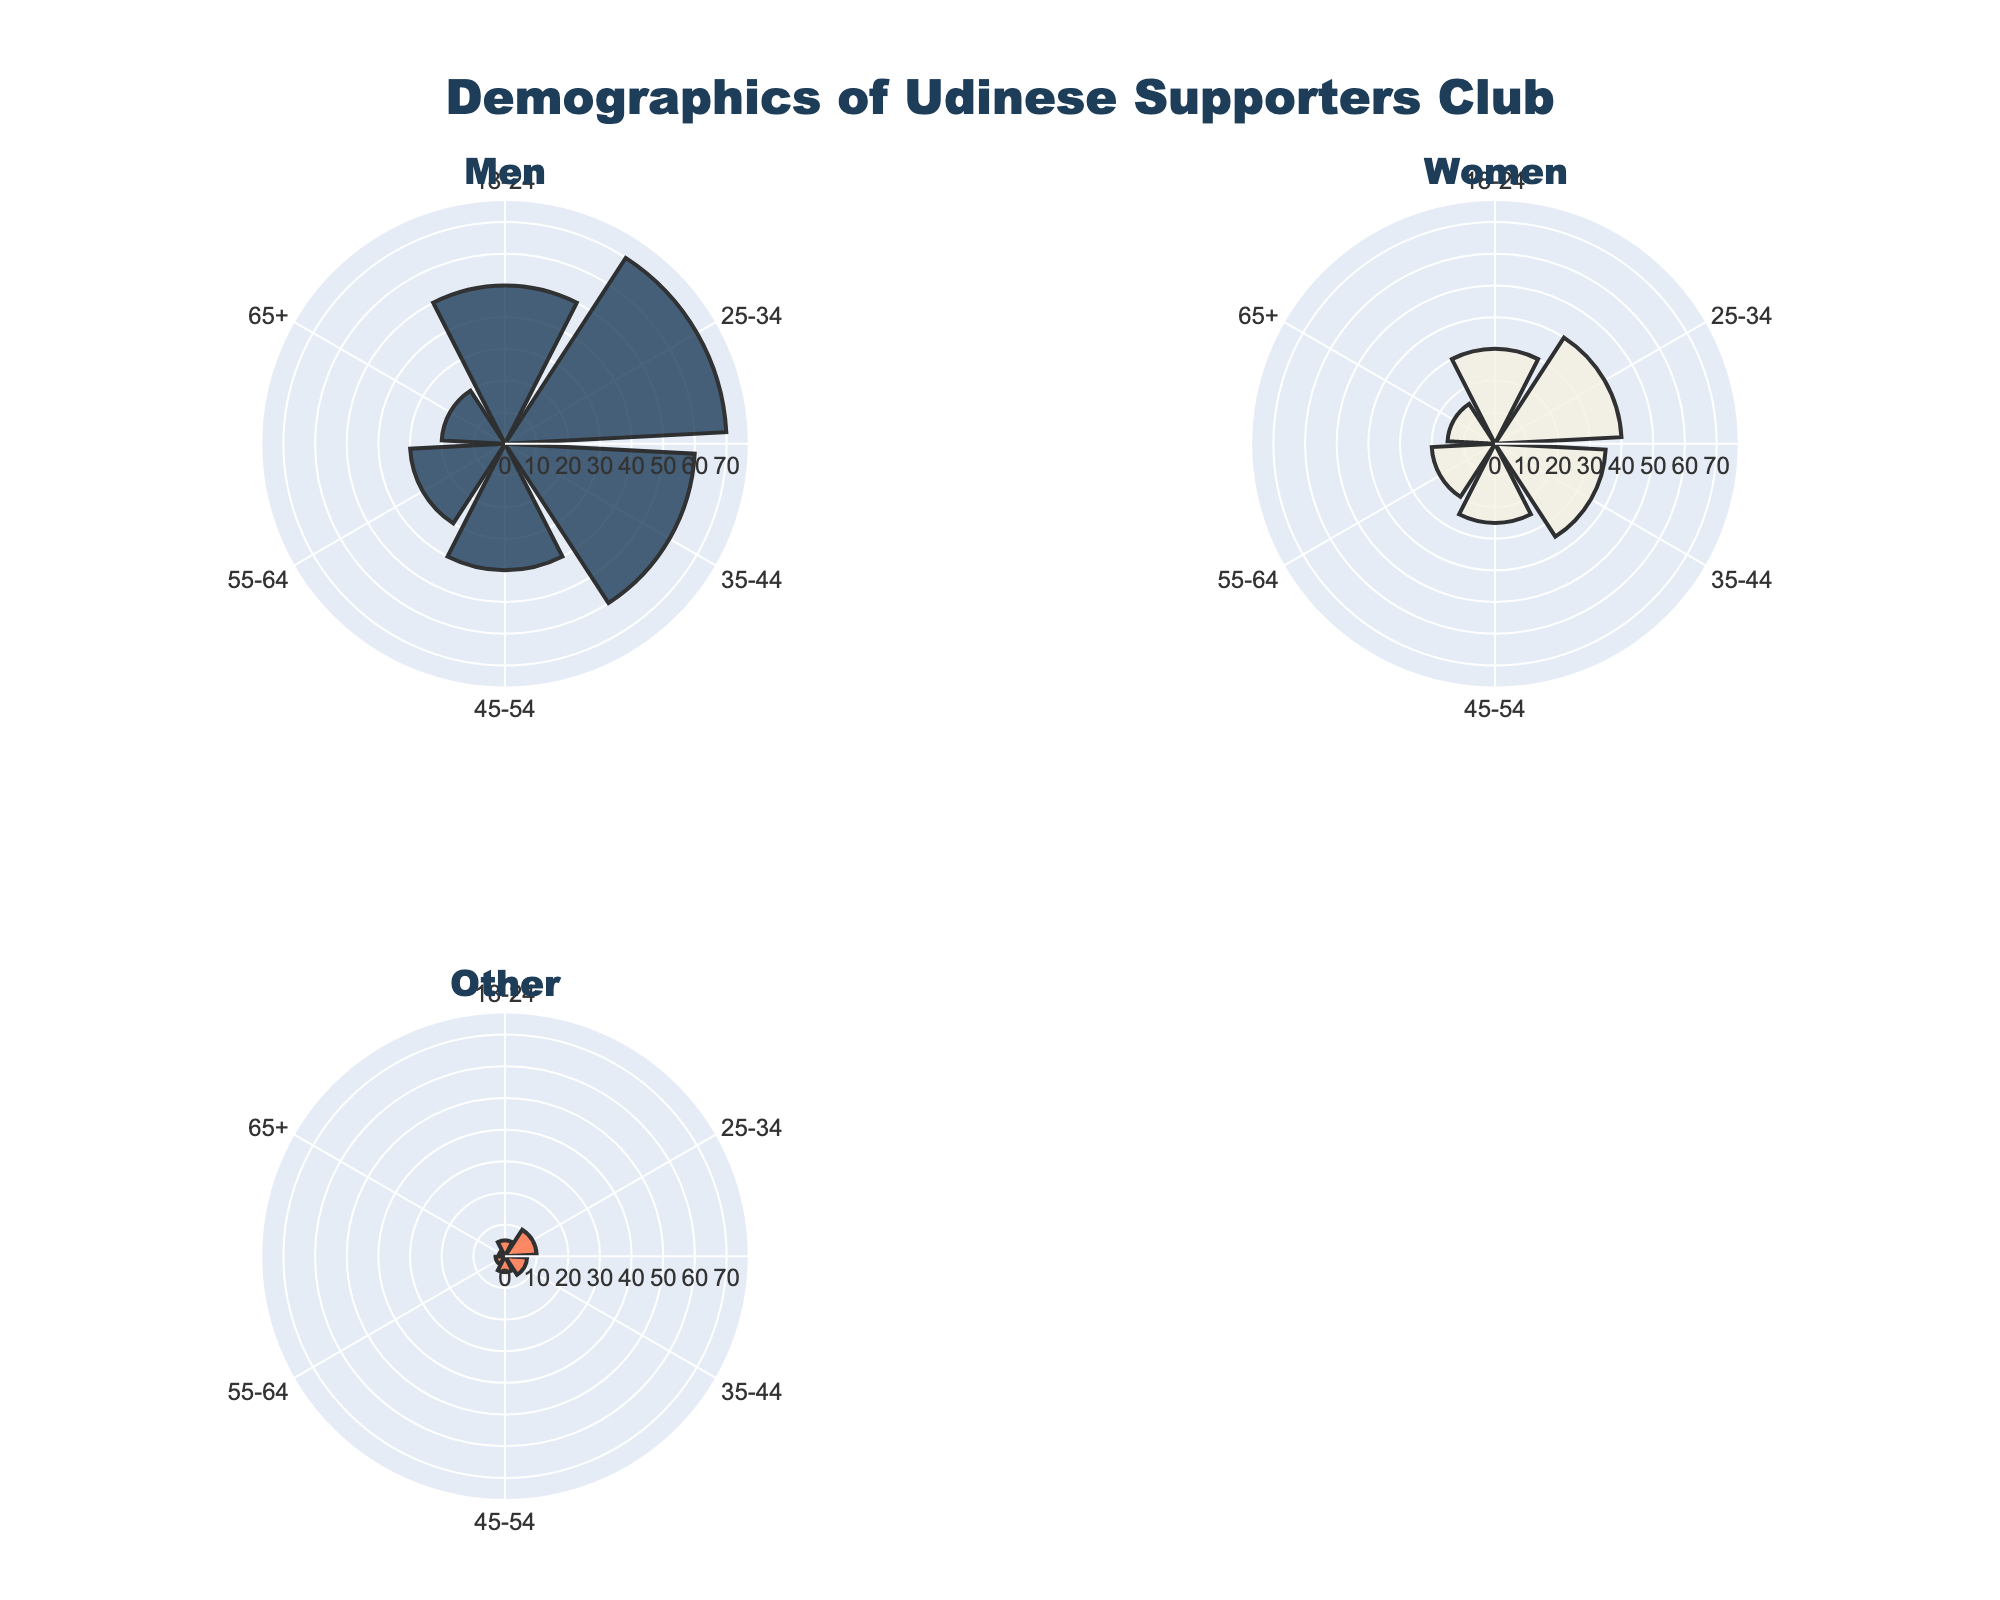What's the title of the plot? The title of the plot is usually displayed at the top and gives an overview of the visualization's content. Here it reads "Demographics of Udinese Supporters Club."
Answer: Demographics of Udinese Supporters Club How many age groups are represented in the plot? The age groups are indicated by labels on the radial axis of each rose chart. There are six different age groups shown: 18-24, 25-34, 35-44, 45-54, 55-64, and 65+. Carefully counting these labels confirms the total.
Answer: 6 Which age group has the highest count in the Men category? By examining the Barpolar trace for the Men category, we see the bar representing 25-34 age group extends further than any other, indicating it has the highest count of 70 individuals.
Answer: 25-34 Compare the 18-24 age group counts for Men and Women. Which group is larger and by how much? Referring to the rose charts for both Men and Women, we note the counts: Men (50) and Women (30). Subtracting these tells us that the Men group is larger by 20 individuals.
Answer: Men by 20 In which age group do 'Other' category members have the least representation? Looking at the rose chart for the 'Other' category, the 65+ age group has the least bar extension with a count of 2, compared to other age groups.
Answer: 65+ What's the combined count for the 35-44 age group across all categories? Adding the counts from the relevant traces: Men (60), Women (35), Other (7), we get a total of 102.
Answer: 102 How do the counts for Men and Women in the 55-64 age group compare? Looking at the respective rose charts, Men count (30) is higher than Women count (20). The comparison shows Men have 10 more members in this age group.
Answer: Men have 10 more What is the overall trend in membership counts across age groups for the Men category? Observing the Men category shows initial growth from 18-24 to 25-34, a peak at 25-34, then a declining trend through successive age groups.
Answer: Peak at 25-34 then declines Which age group has nearly equal representation among Women and Other categories? The 45-54 age group shows counts: Women (25) and Other (5), where the ratio, though not equal, is the closest in comparison across categories.
Answer: 45-54 Which category shows relatively consistent membership representation across all age groups? The 'Other' category shows minor fluctuation with lower counts, displaying relatively consistent representation from one age group to another.
Answer: Other 